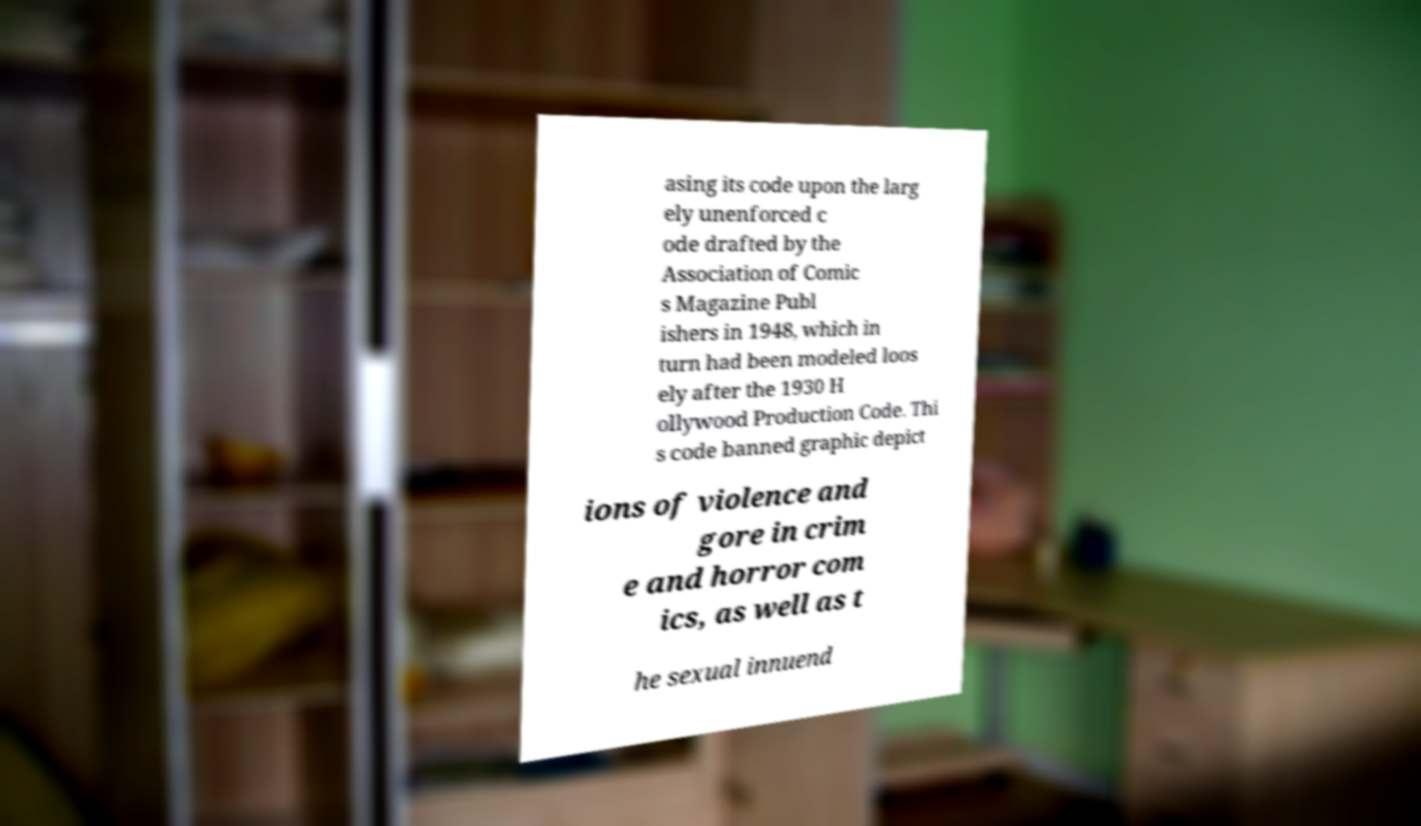There's text embedded in this image that I need extracted. Can you transcribe it verbatim? asing its code upon the larg ely unenforced c ode drafted by the Association of Comic s Magazine Publ ishers in 1948, which in turn had been modeled loos ely after the 1930 H ollywood Production Code. Thi s code banned graphic depict ions of violence and gore in crim e and horror com ics, as well as t he sexual innuend 